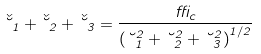<formula> <loc_0><loc_0><loc_500><loc_500>\check { \lambda } _ { 1 } + \check { \lambda } _ { 2 } + \check { \lambda } _ { 3 } = \frac { \delta _ { c } } { \left ( \lambda ^ { 2 } _ { 1 } + \lambda ^ { 2 } _ { 2 } + \lambda ^ { 2 } _ { 3 } \right ) ^ { 1 / 2 } }</formula> 